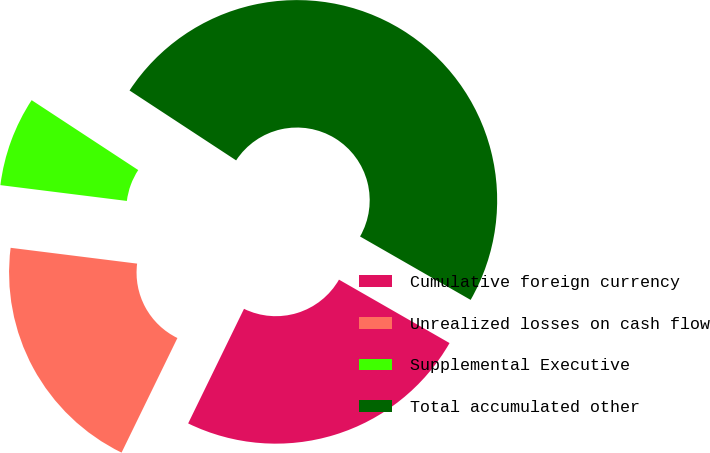Convert chart. <chart><loc_0><loc_0><loc_500><loc_500><pie_chart><fcel>Cumulative foreign currency<fcel>Unrealized losses on cash flow<fcel>Supplemental Executive<fcel>Total accumulated other<nl><fcel>23.93%<fcel>19.76%<fcel>7.26%<fcel>49.05%<nl></chart> 